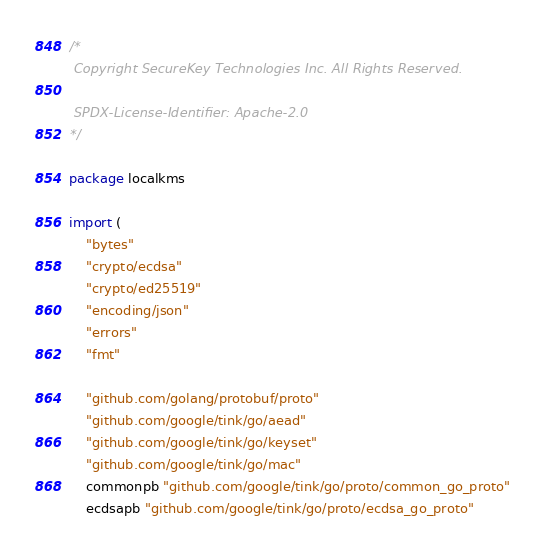<code> <loc_0><loc_0><loc_500><loc_500><_Go_>/*
 Copyright SecureKey Technologies Inc. All Rights Reserved.

 SPDX-License-Identifier: Apache-2.0
*/

package localkms

import (
	"bytes"
	"crypto/ecdsa"
	"crypto/ed25519"
	"encoding/json"
	"errors"
	"fmt"

	"github.com/golang/protobuf/proto"
	"github.com/google/tink/go/aead"
	"github.com/google/tink/go/keyset"
	"github.com/google/tink/go/mac"
	commonpb "github.com/google/tink/go/proto/common_go_proto"
	ecdsapb "github.com/google/tink/go/proto/ecdsa_go_proto"</code> 